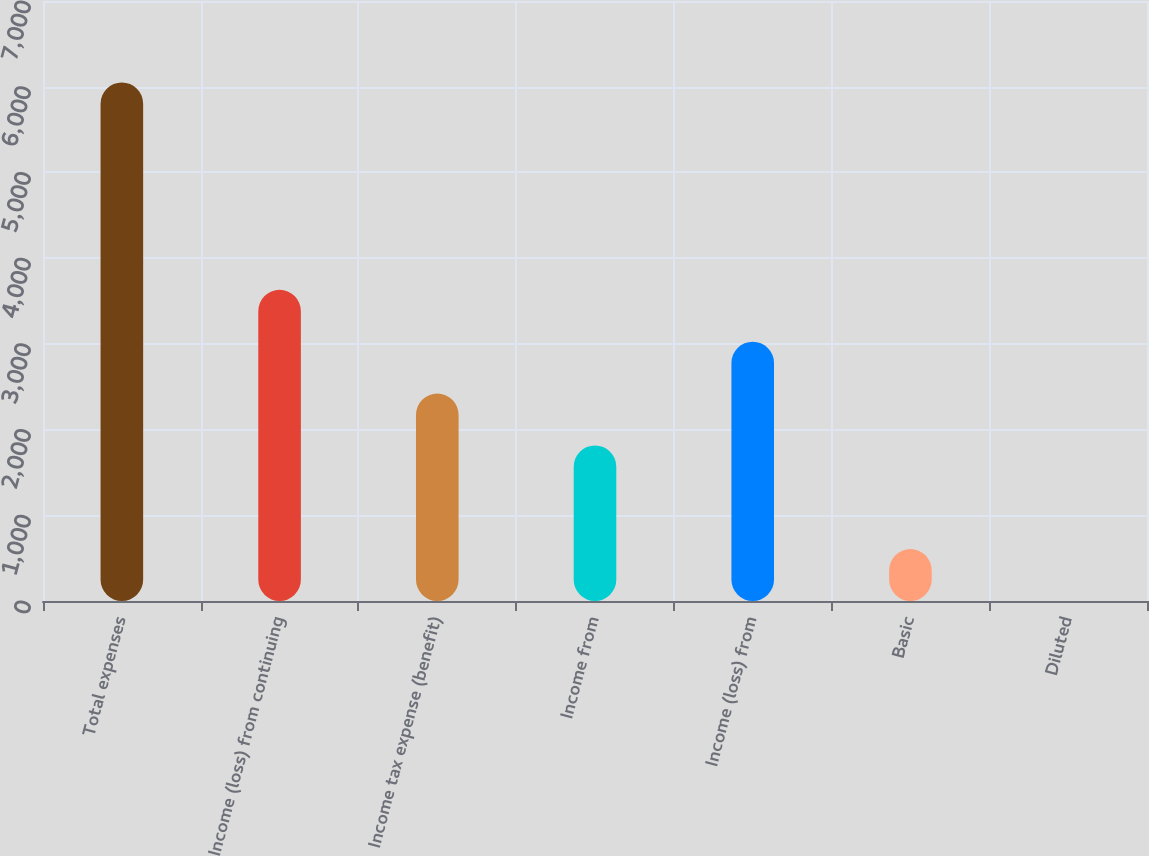Convert chart to OTSL. <chart><loc_0><loc_0><loc_500><loc_500><bar_chart><fcel>Total expenses<fcel>Income (loss) from continuing<fcel>Income tax expense (benefit)<fcel>Income from<fcel>Income (loss) from<fcel>Basic<fcel>Diluted<nl><fcel>6050<fcel>3630.11<fcel>2420.15<fcel>1815.17<fcel>3025.13<fcel>605.21<fcel>0.23<nl></chart> 